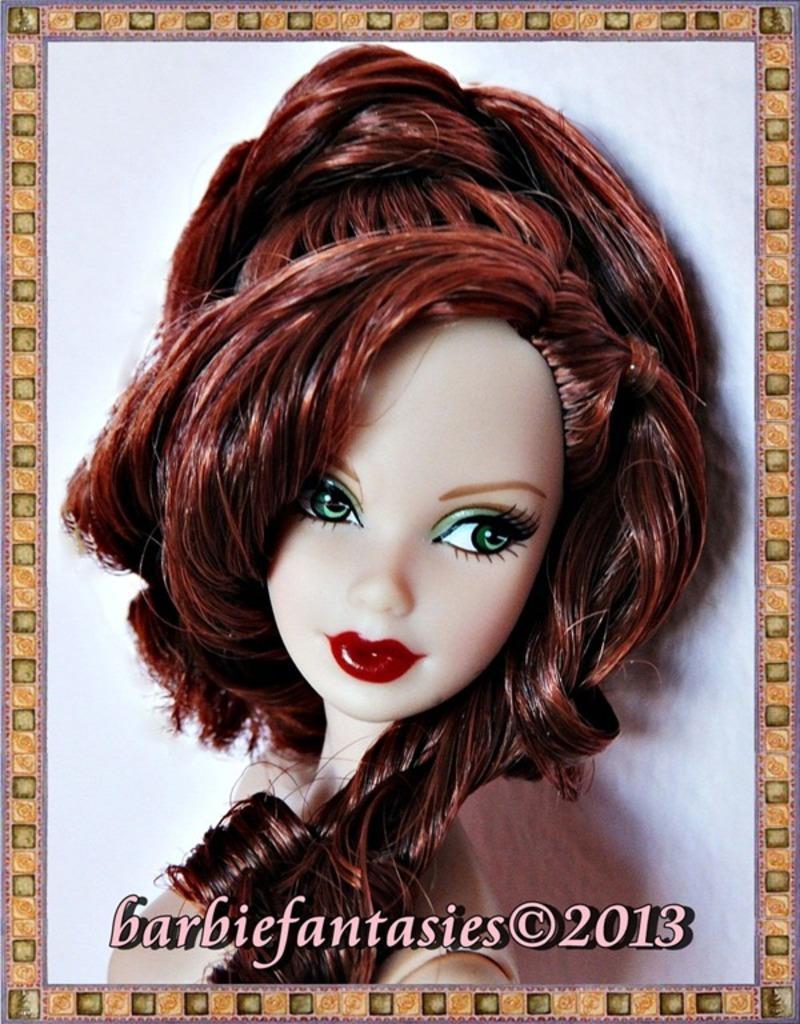Could you give a brief overview of what you see in this image? In this picture we can observe a barbie doll. We can observe green color eyes and brown color hair. We can observe yellow color frame. The background is in white color. 